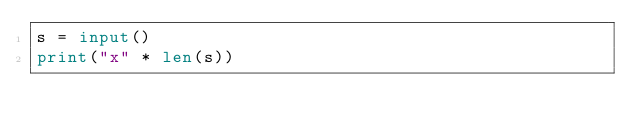Convert code to text. <code><loc_0><loc_0><loc_500><loc_500><_Python_>s = input()
print("x" * len(s))
</code> 